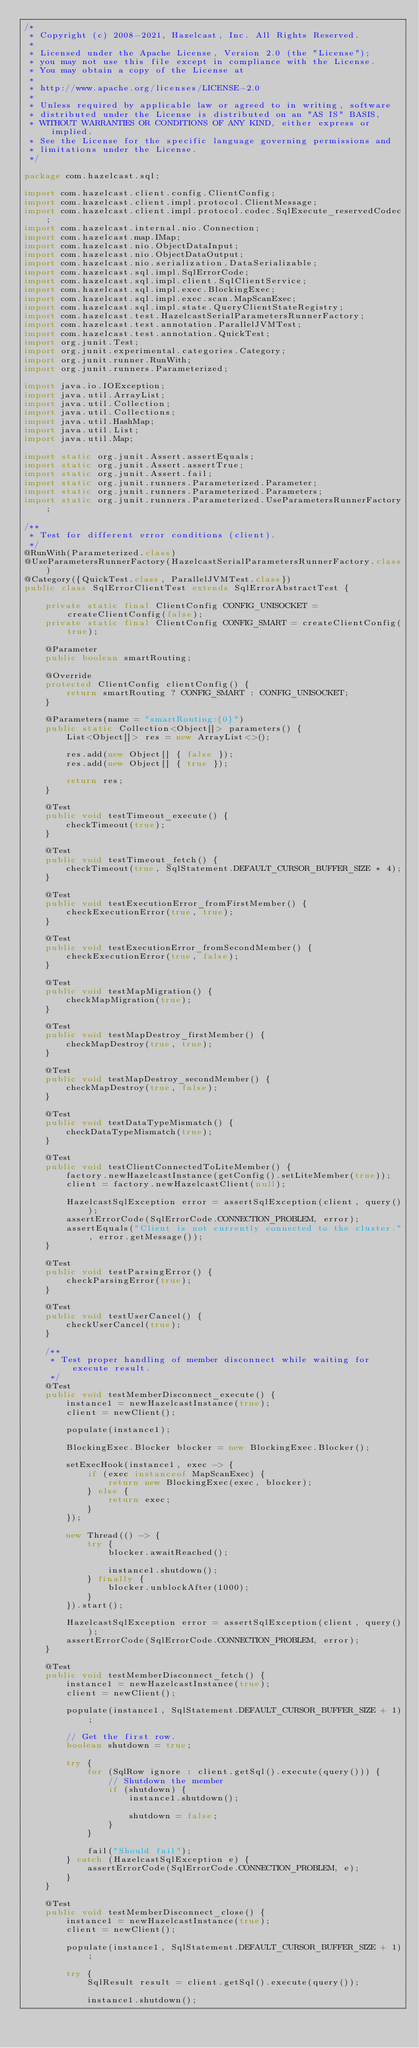Convert code to text. <code><loc_0><loc_0><loc_500><loc_500><_Java_>/*
 * Copyright (c) 2008-2021, Hazelcast, Inc. All Rights Reserved.
 *
 * Licensed under the Apache License, Version 2.0 (the "License");
 * you may not use this file except in compliance with the License.
 * You may obtain a copy of the License at
 *
 * http://www.apache.org/licenses/LICENSE-2.0
 *
 * Unless required by applicable law or agreed to in writing, software
 * distributed under the License is distributed on an "AS IS" BASIS,
 * WITHOUT WARRANTIES OR CONDITIONS OF ANY KIND, either express or implied.
 * See the License for the specific language governing permissions and
 * limitations under the License.
 */

package com.hazelcast.sql;

import com.hazelcast.client.config.ClientConfig;
import com.hazelcast.client.impl.protocol.ClientMessage;
import com.hazelcast.client.impl.protocol.codec.SqlExecute_reservedCodec;
import com.hazelcast.internal.nio.Connection;
import com.hazelcast.map.IMap;
import com.hazelcast.nio.ObjectDataInput;
import com.hazelcast.nio.ObjectDataOutput;
import com.hazelcast.nio.serialization.DataSerializable;
import com.hazelcast.sql.impl.SqlErrorCode;
import com.hazelcast.sql.impl.client.SqlClientService;
import com.hazelcast.sql.impl.exec.BlockingExec;
import com.hazelcast.sql.impl.exec.scan.MapScanExec;
import com.hazelcast.sql.impl.state.QueryClientStateRegistry;
import com.hazelcast.test.HazelcastSerialParametersRunnerFactory;
import com.hazelcast.test.annotation.ParallelJVMTest;
import com.hazelcast.test.annotation.QuickTest;
import org.junit.Test;
import org.junit.experimental.categories.Category;
import org.junit.runner.RunWith;
import org.junit.runners.Parameterized;

import java.io.IOException;
import java.util.ArrayList;
import java.util.Collection;
import java.util.Collections;
import java.util.HashMap;
import java.util.List;
import java.util.Map;

import static org.junit.Assert.assertEquals;
import static org.junit.Assert.assertTrue;
import static org.junit.Assert.fail;
import static org.junit.runners.Parameterized.Parameter;
import static org.junit.runners.Parameterized.Parameters;
import static org.junit.runners.Parameterized.UseParametersRunnerFactory;

/**
 * Test for different error conditions (client).
 */
@RunWith(Parameterized.class)
@UseParametersRunnerFactory(HazelcastSerialParametersRunnerFactory.class)
@Category({QuickTest.class, ParallelJVMTest.class})
public class SqlErrorClientTest extends SqlErrorAbstractTest {

    private static final ClientConfig CONFIG_UNISOCKET = createClientConfig(false);
    private static final ClientConfig CONFIG_SMART = createClientConfig(true);

    @Parameter
    public boolean smartRouting;

    @Override
    protected ClientConfig clientConfig() {
        return smartRouting ? CONFIG_SMART : CONFIG_UNISOCKET;
    }

    @Parameters(name = "smartRouting:{0}")
    public static Collection<Object[]> parameters() {
        List<Object[]> res = new ArrayList<>();

        res.add(new Object[] { false });
        res.add(new Object[] { true });

        return res;
    }

    @Test
    public void testTimeout_execute() {
        checkTimeout(true);
    }

    @Test
    public void testTimeout_fetch() {
        checkTimeout(true, SqlStatement.DEFAULT_CURSOR_BUFFER_SIZE * 4);
    }

    @Test
    public void testExecutionError_fromFirstMember() {
        checkExecutionError(true, true);
    }

    @Test
    public void testExecutionError_fromSecondMember() {
        checkExecutionError(true, false);
    }

    @Test
    public void testMapMigration() {
        checkMapMigration(true);
    }

    @Test
    public void testMapDestroy_firstMember() {
        checkMapDestroy(true, true);
    }

    @Test
    public void testMapDestroy_secondMember() {
        checkMapDestroy(true, false);
    }

    @Test
    public void testDataTypeMismatch() {
        checkDataTypeMismatch(true);
    }

    @Test
    public void testClientConnectedToLiteMember() {
        factory.newHazelcastInstance(getConfig().setLiteMember(true));
        client = factory.newHazelcastClient(null);

        HazelcastSqlException error = assertSqlException(client, query());
        assertErrorCode(SqlErrorCode.CONNECTION_PROBLEM, error);
        assertEquals("Client is not currently connected to the cluster.", error.getMessage());
    }

    @Test
    public void testParsingError() {
        checkParsingError(true);
    }

    @Test
    public void testUserCancel() {
        checkUserCancel(true);
    }

    /**
     * Test proper handling of member disconnect while waiting for execute result.
     */
    @Test
    public void testMemberDisconnect_execute() {
        instance1 = newHazelcastInstance(true);
        client = newClient();

        populate(instance1);

        BlockingExec.Blocker blocker = new BlockingExec.Blocker();

        setExecHook(instance1, exec -> {
            if (exec instanceof MapScanExec) {
                return new BlockingExec(exec, blocker);
            } else {
                return exec;
            }
        });

        new Thread(() -> {
            try {
                blocker.awaitReached();

                instance1.shutdown();
            } finally {
                blocker.unblockAfter(1000);
            }
        }).start();

        HazelcastSqlException error = assertSqlException(client, query());
        assertErrorCode(SqlErrorCode.CONNECTION_PROBLEM, error);
    }

    @Test
    public void testMemberDisconnect_fetch() {
        instance1 = newHazelcastInstance(true);
        client = newClient();

        populate(instance1, SqlStatement.DEFAULT_CURSOR_BUFFER_SIZE + 1);

        // Get the first row.
        boolean shutdown = true;

        try {
            for (SqlRow ignore : client.getSql().execute(query())) {
                // Shutdown the member
                if (shutdown) {
                    instance1.shutdown();

                    shutdown = false;
                }
            }

            fail("Should fail");
        } catch (HazelcastSqlException e) {
            assertErrorCode(SqlErrorCode.CONNECTION_PROBLEM, e);
        }
    }

    @Test
    public void testMemberDisconnect_close() {
        instance1 = newHazelcastInstance(true);
        client = newClient();

        populate(instance1, SqlStatement.DEFAULT_CURSOR_BUFFER_SIZE + 1);

        try {
            SqlResult result = client.getSql().execute(query());

            instance1.shutdown();
</code> 